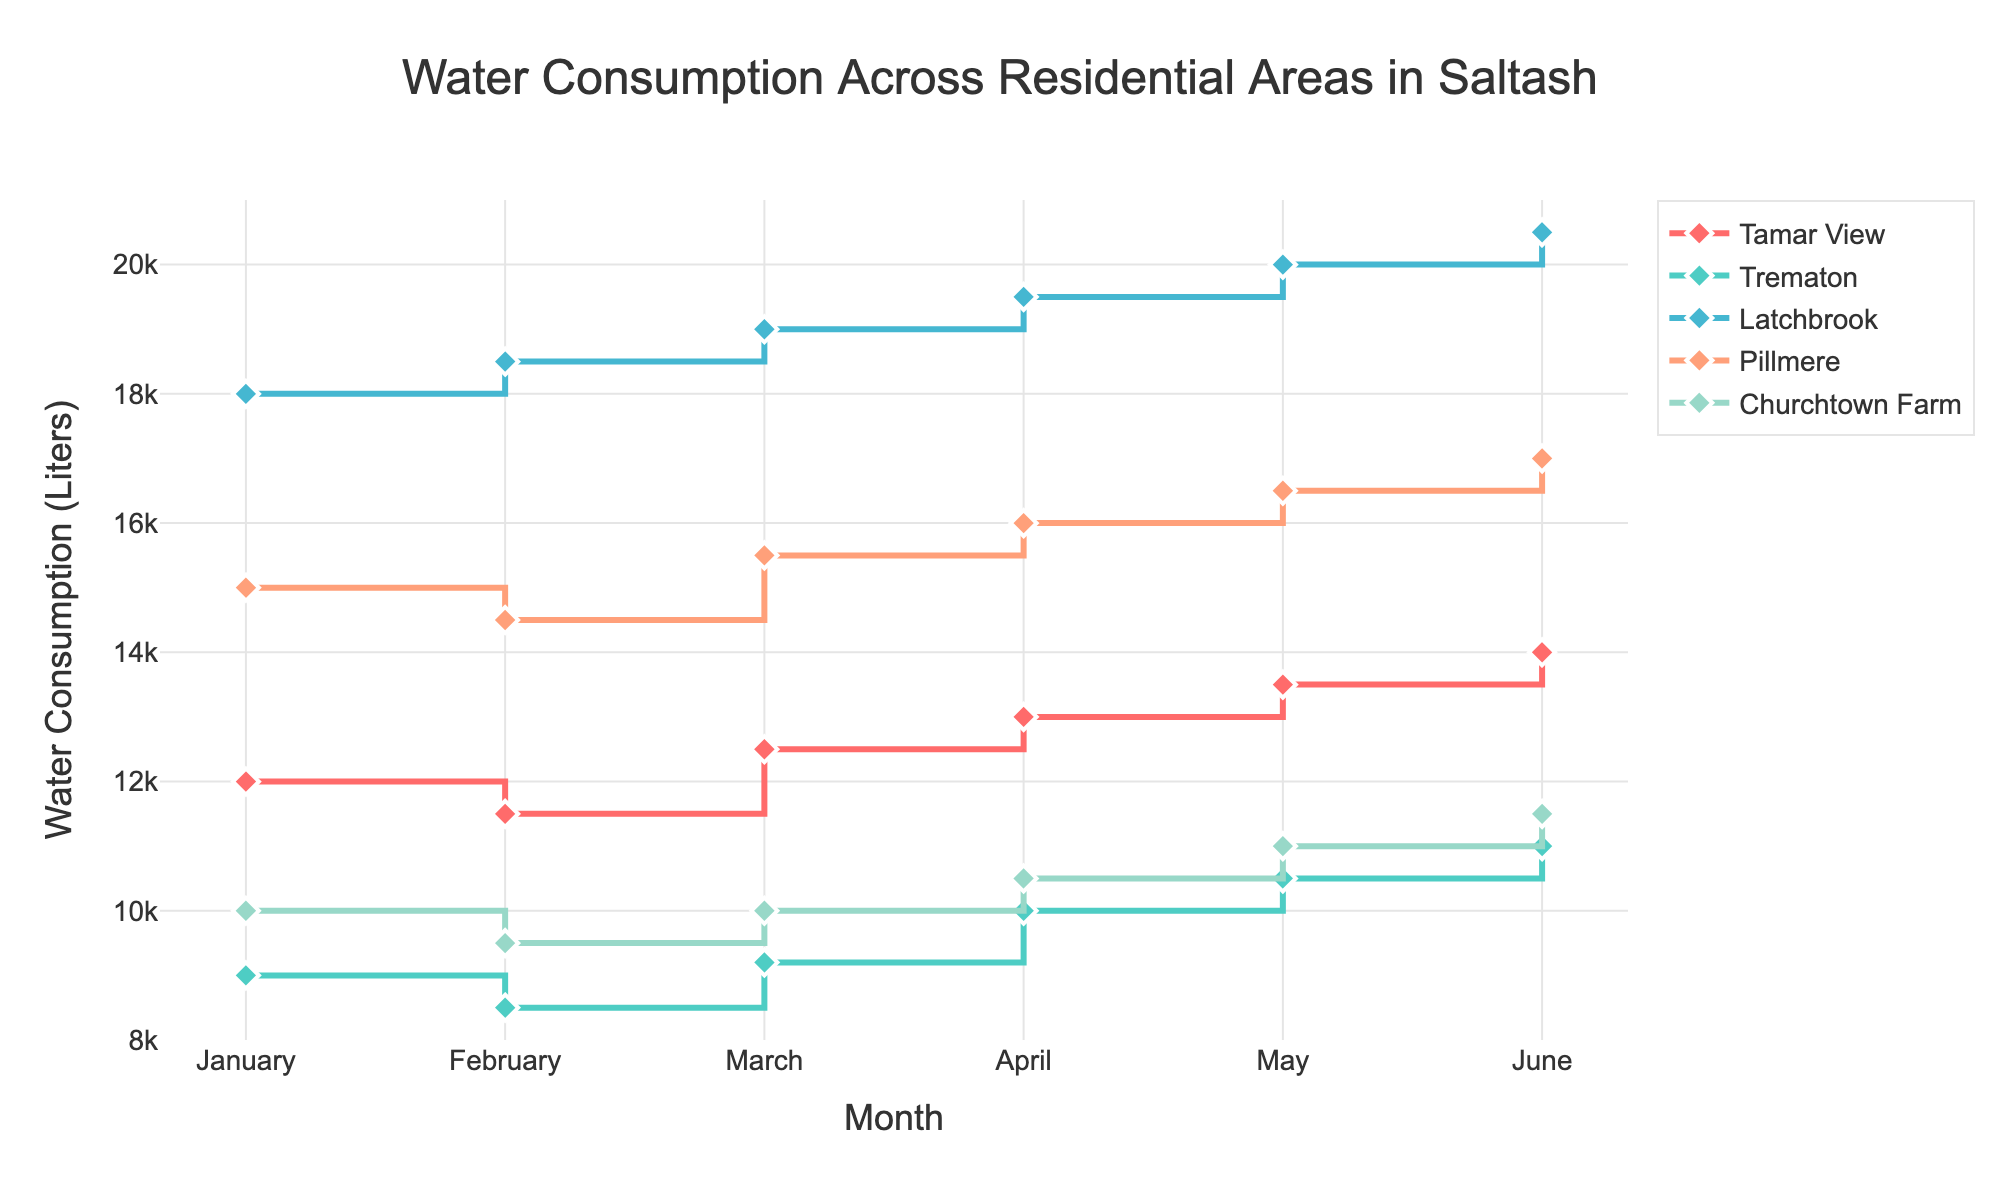How many residential areas are included in the figure? The figure shows lines for different residential areas, and there's a legend to identify them. By counting the distinct names in the legend, we can determine the number of areas.
Answer: 5 What is the water consumption trend for Latchbrook from January to June? By looking at the line for Latchbrook and following the water consumption values from January to June, we can describe the trend. The line steadily increases from January (18000 Liters) to June (20500 Liters).
Answer: Increasing Which residential area had the lowest water consumption in January? We identify the water consumption values for all areas in January and look for the smallest number. Tamar View: 12000, Trematon: 9000, Latchbrook: 18000, Pillmere: 15000, Churchtown Farm: 10000.
Answer: Trematon What is the difference in water consumption between Trematon and Pillmere in February? First, find the values for Trematon (8500 Liters) and Pillmere (14500 Liters) in February. Then, calculate the difference: 14500 - 8500 = 6000.
Answer: 6000 Liters Which month had the highest water consumption in any residential area, and which area was it? Track the highest value on the y-axis across all lines and months. The highest value is 20500 Liters in June for Latchbrook.
Answer: June, Latchbrook What is the average water consumption in Tamar View for the first quarter (January to March)? Add the values for January (12000 Liters), February (11500 Liters), and March (12500 Liters). Then divide by 3: (12000 + 11500 + 12500) / 3 = 12000.
Answer: 12000 Liters Compare the water consumption between Churchtown Farm and Tamar View in April. Which area had higher consumption, and by how much? Churchtown Farm: 10500 Liters, Tamar View: 13000 Liters. Tamar View had higher consumption. The difference is 13000 - 10500 = 2500.
Answer: Tamar View, 2500 Liters Is there any month where all areas had increasing water consumption compared to the previous month? Inspect the lines for each month and compare values to the previous month for all areas. From April to May, all areas show an increase: Tamar View (13000 to 13500), Trematon (10000 to 10500), Latchbrook (19500 to 20000), Pillmere (16000 to 16500), Churchtown Farm (10500 to 11000).
Answer: May How does the water consumption in May compare across the different areas? Look at the water consumption values in May for all areas: Tamar View (13500 Liters), Trematon (10500 Liters), Latchbrook (20000 Liters), Pillmere (16500 Liters), Churchtown Farm (11000 Liters). Latchbrook had the highest, and Trematon had the lowest.
Answer: Latchbrook highest, Trematon lowest 